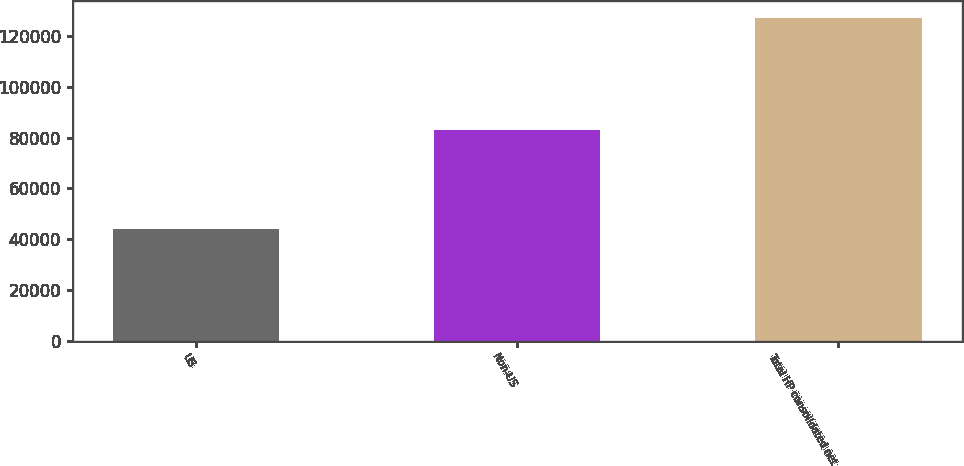<chart> <loc_0><loc_0><loc_500><loc_500><bar_chart><fcel>US<fcel>Non-US<fcel>Total HP consolidated net<nl><fcel>44111<fcel>83134<fcel>127245<nl></chart> 